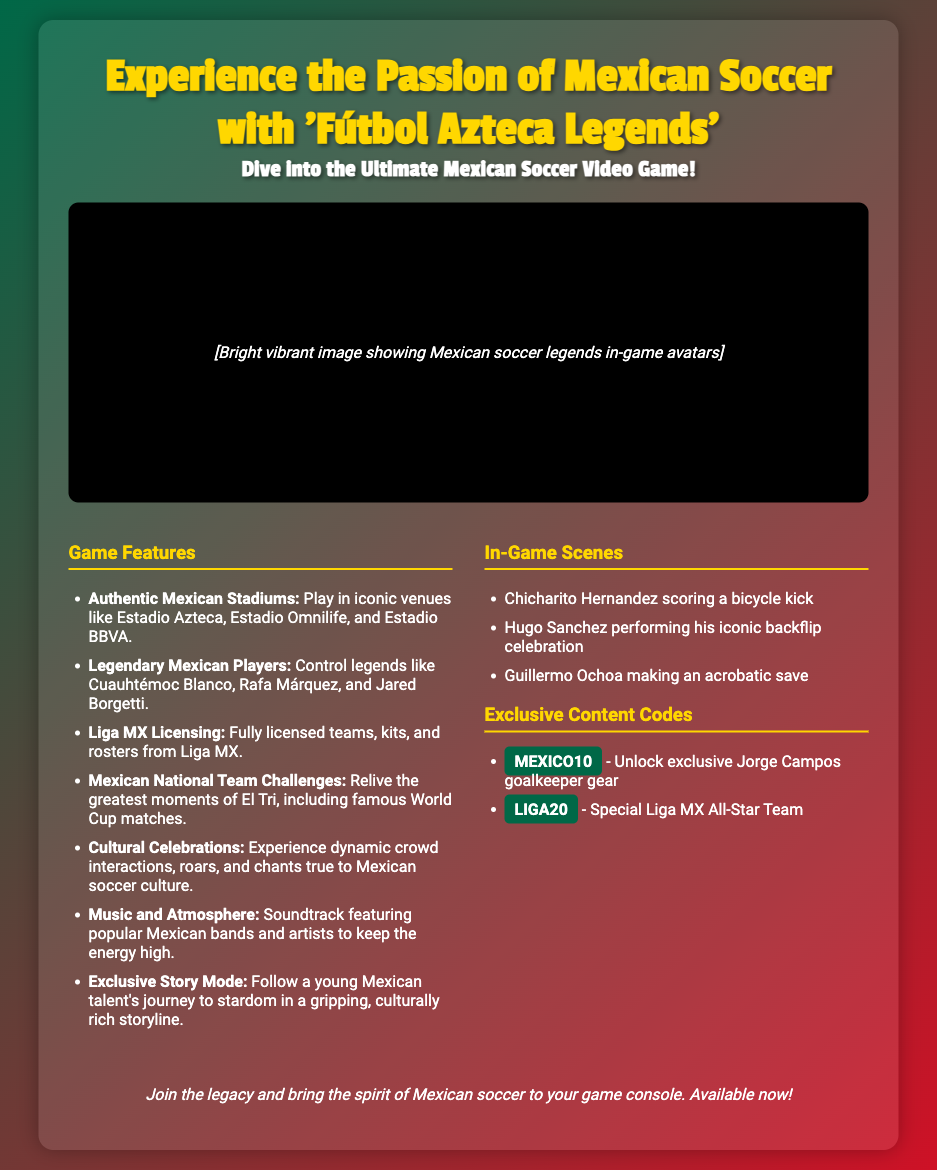What is the name of the game? The game is titled "Fútbol Azteca Legends."
Answer: Fútbol Azteca Legends Which stadiums are featured in the game? The document lists several stadiums including Estadio Azteca, Estadio Omnilife, and Estadio BBVA.
Answer: Estadio Azteca, Estadio Omnilife, Estadio BBVA What is the exclusive story mode about? The exclusive story mode follows a young Mexican talent's journey to stardom.
Answer: Young Mexican talent's journey to stardom Who is a legendary player featured in the game? The document mentions legends such as Cuauhtémoc Blanco, Rafa Márquez, and Jared Borgetti.
Answer: Cuauhtémoc Blanco What content code unlocks exclusive Jorge Campos gear? The content code for unlocking exclusive Jorge Campos goalkeeper gear is MEXICO10.
Answer: MEXICO10 